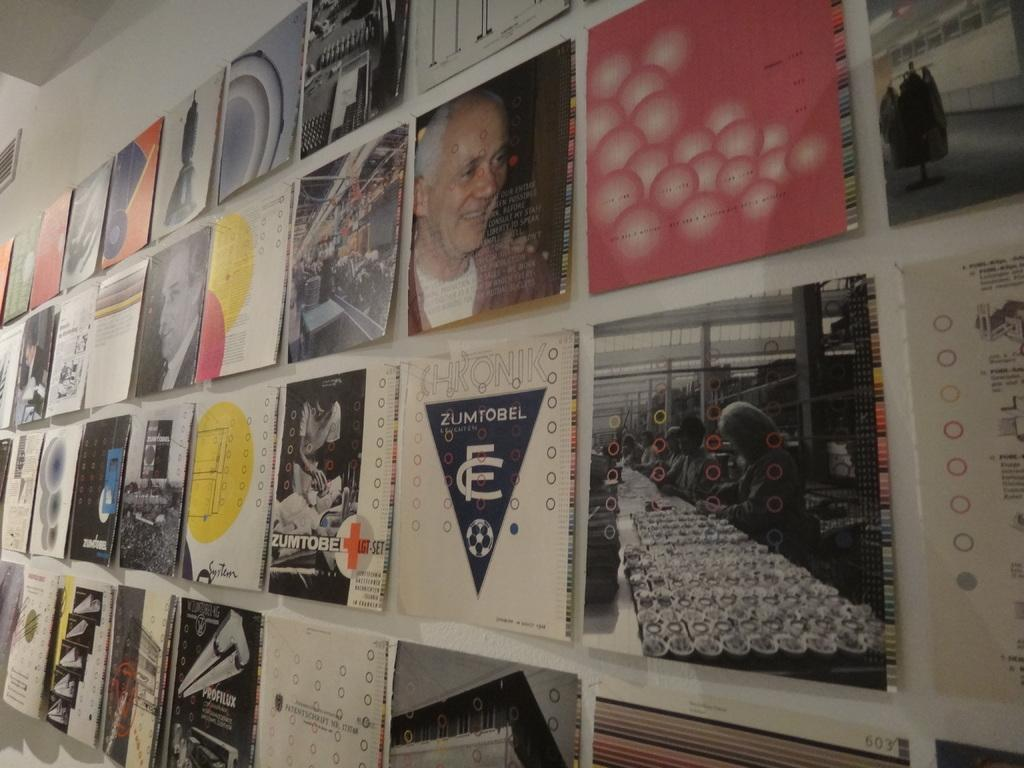<image>
Share a concise interpretation of the image provided. Many pages are displayed on a board including one with Zumtobel. 